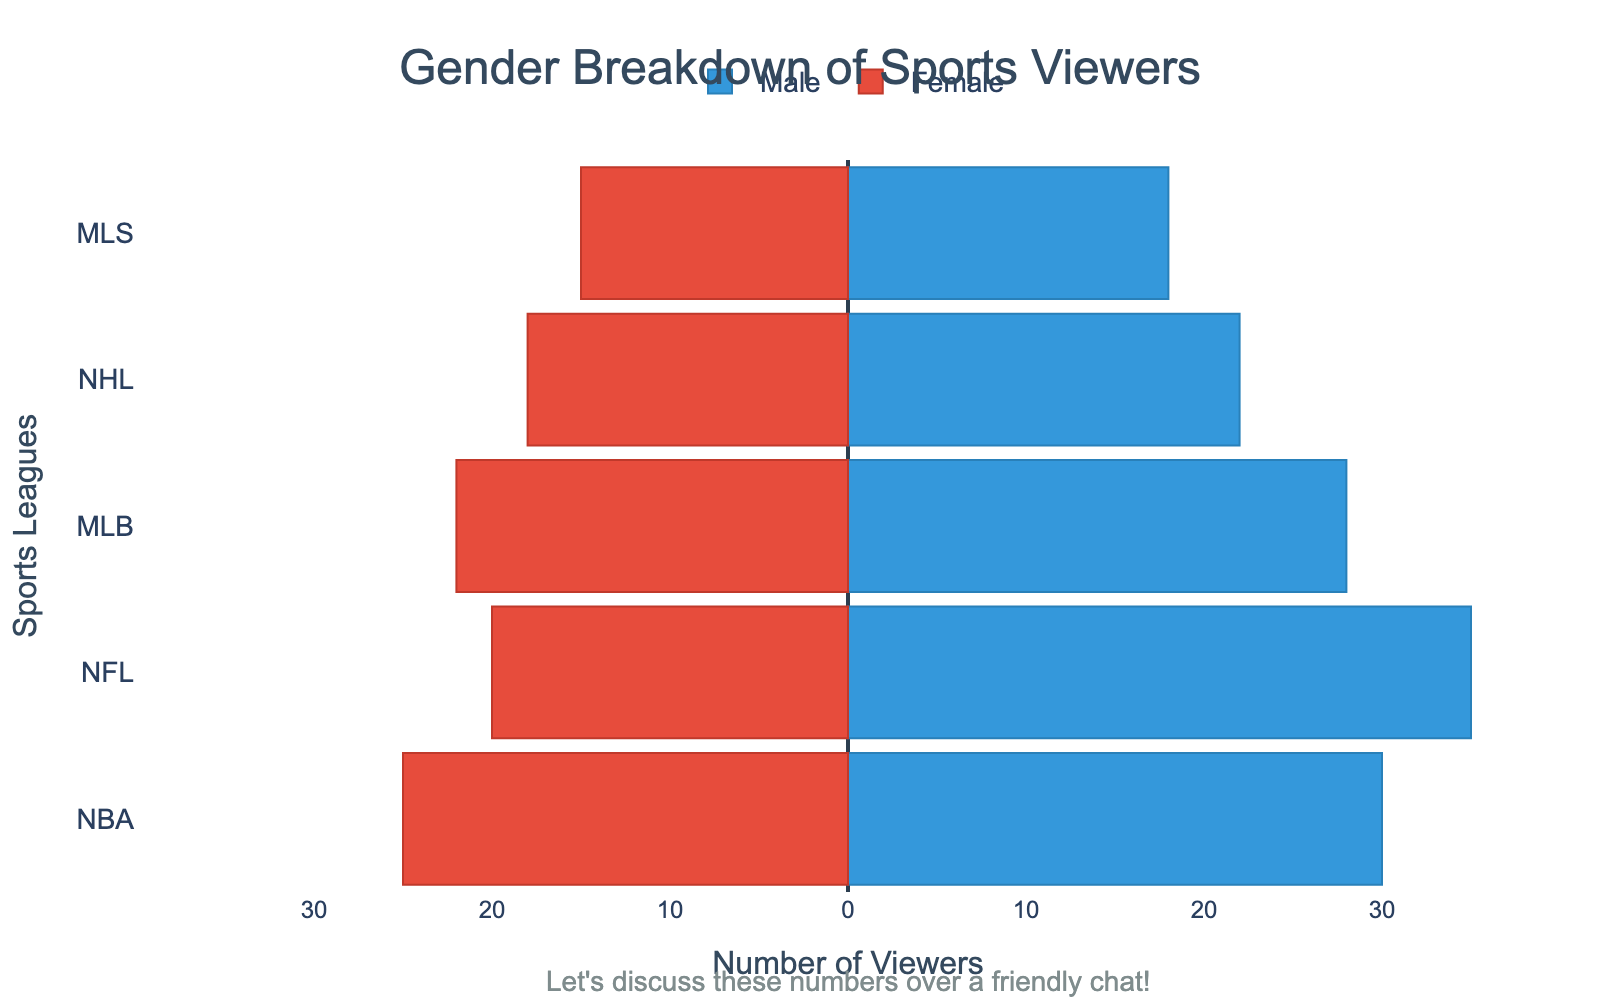What's the title of the figure? The title of the figure is located at the top center of the chart and reads "Gender Breakdown of Sports Viewers"
Answer: Gender Breakdown of Sports Viewers Which gender has more viewers for NBA? Look at the NBA bars on the chart and compare the lengths; the Male bar is longer than the Female bar, indicating more male viewers.
Answer: Male How many female viewers watch MLS? Locate the Female bar corresponding to MLS, which extends to -15, signifying 15 female viewers.
Answer: 15 What is the total number of male viewers across all leagues? Sum the Male values: 30 (NBA) + 35 (NFL) + 28 (MLB) + 22 (NHL) + 18 (MLS). The total is 133.
Answer: 133 Which league has the closest number of male and female viewers? Compare the lengths of Male and Female bars for each league; NBA has 30 male and 25 female viewers, making the difference 5, which is the smallest gap.
Answer: NBA What is the range of the scales used on the x-axis? The x-axis values range from -40 to 40, as shown by the tick marks and corresponding labels.
Answer: -40 to 40 Does any league have fewer than 20 male viewers? Check the Male bars for values below 20; the MLS bar is at 18, which fits this criterion.
Answer: Yes Which league has the most significant gender disparity? Calculate the difference between Male and Female viewers for each league. NFL has 35 male and 20 female viewers, giving a disparity of 15, which is the highest.
Answer: NFL How many more male viewers are there for NHL compared to female viewers? NHL has 22 male viewers and 18 female viewers. The difference is 22 - 18 = 4.
Answer: 4 